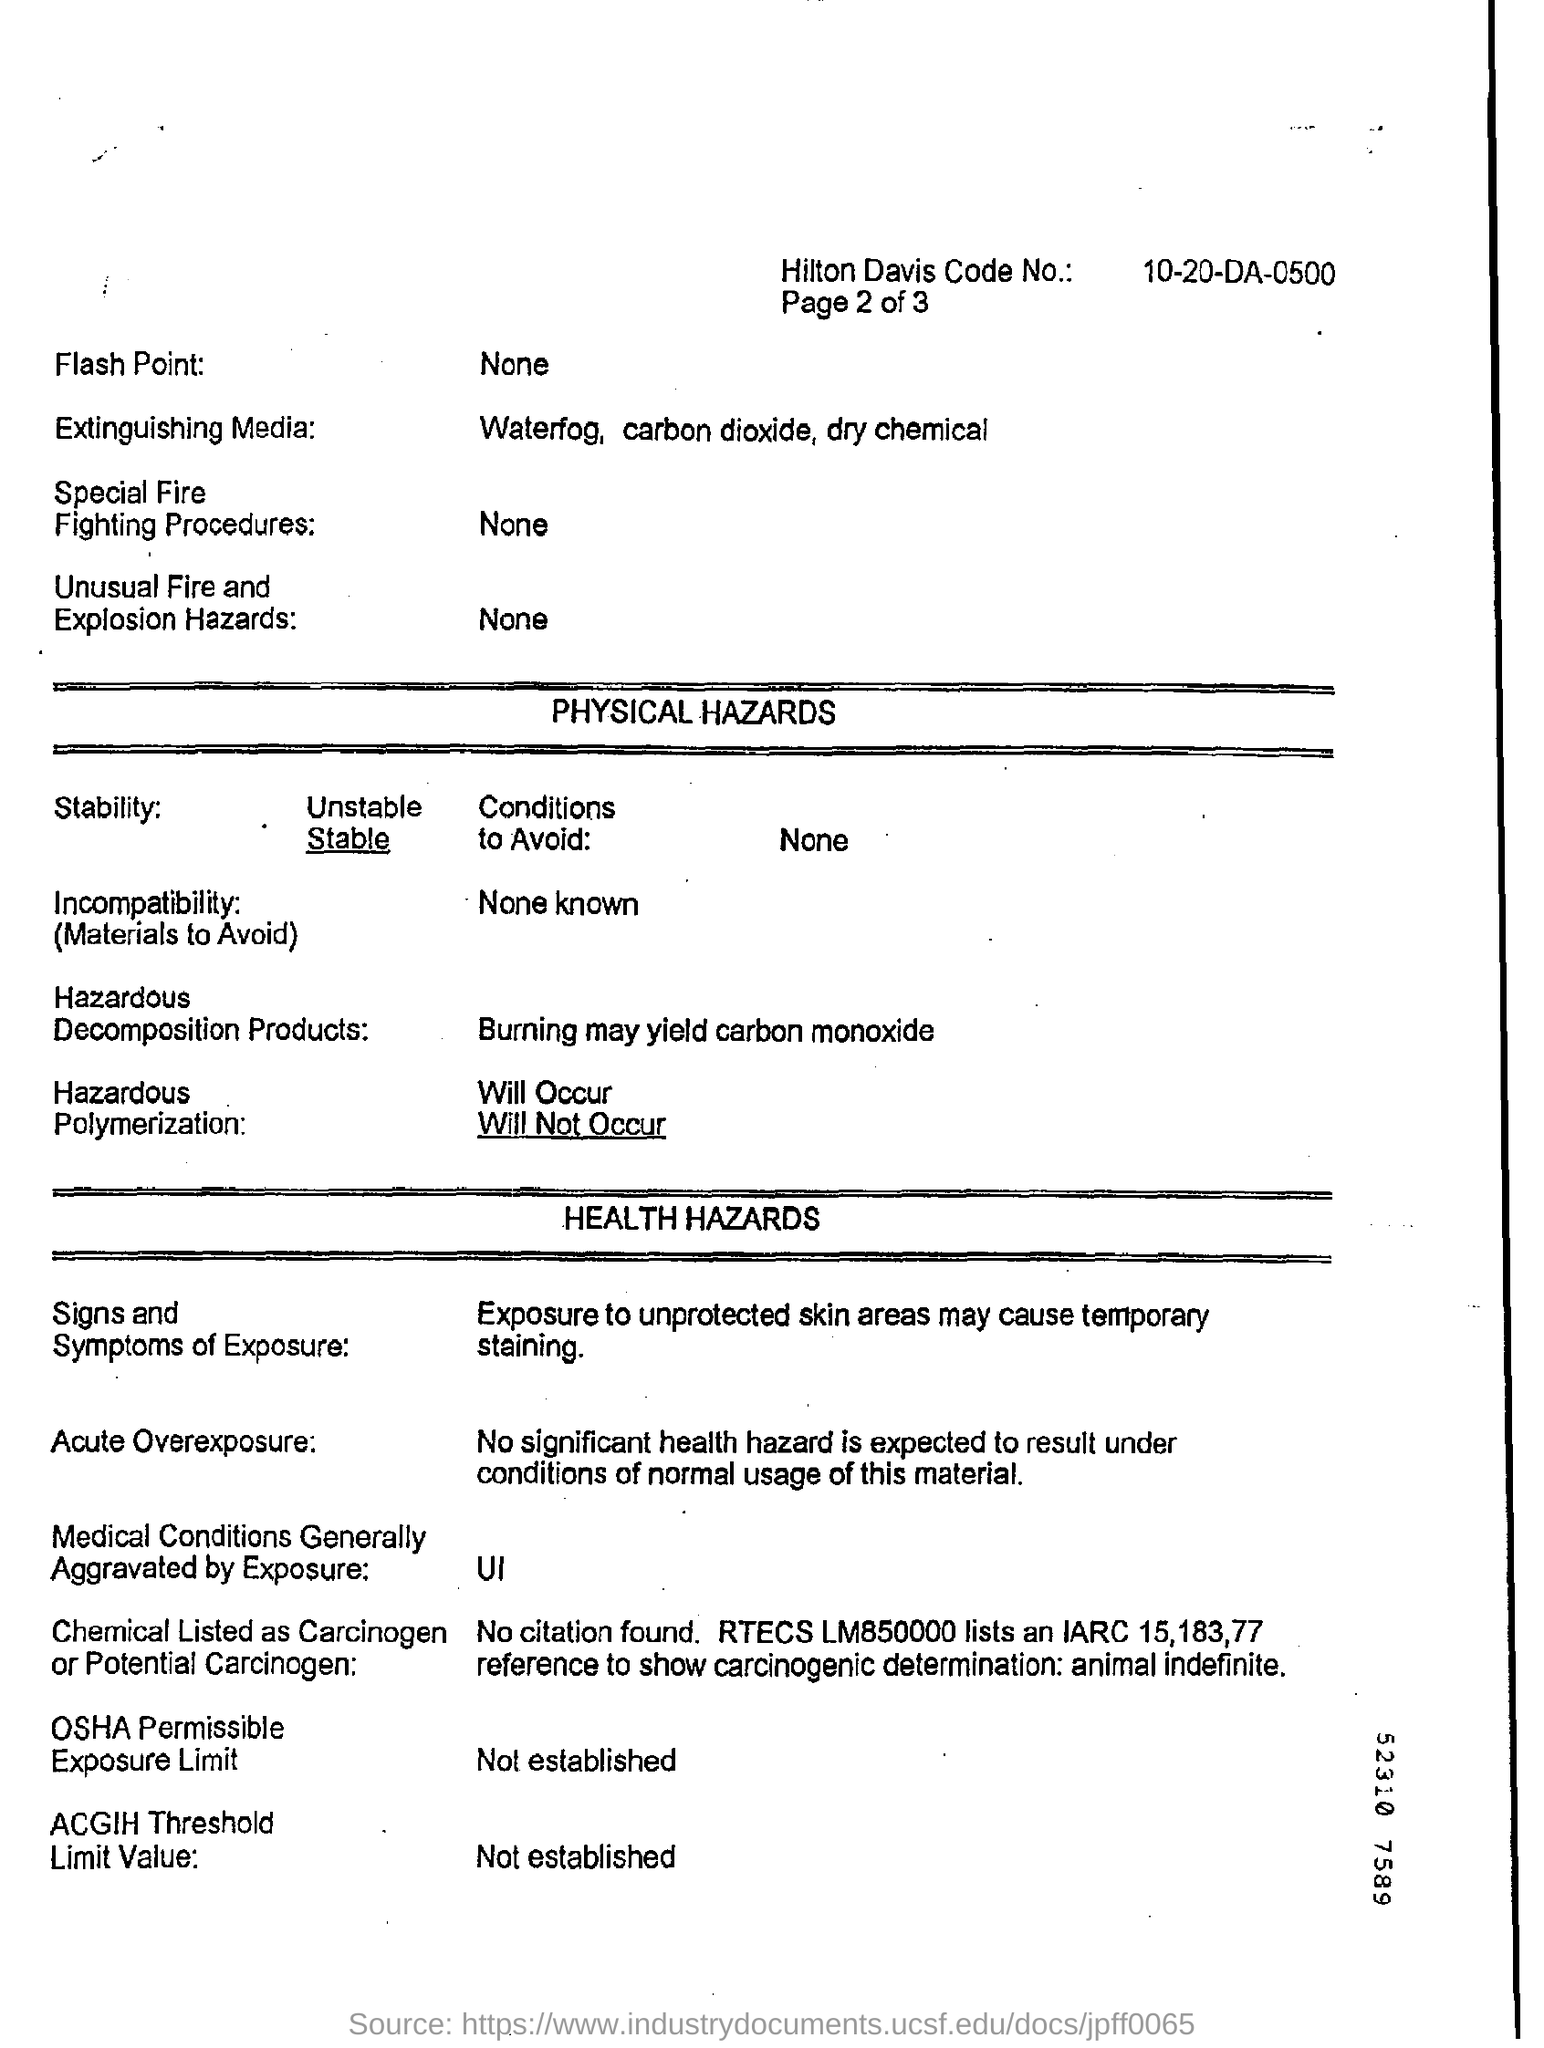What is the Hilton Davis Code No.?
Offer a very short reply. 10-20-DA-0500. What is the Extinguishing Media?
Ensure brevity in your answer.  Waterfog. Will hazardous polymerization occur?
Ensure brevity in your answer.  Will Not Occur. 